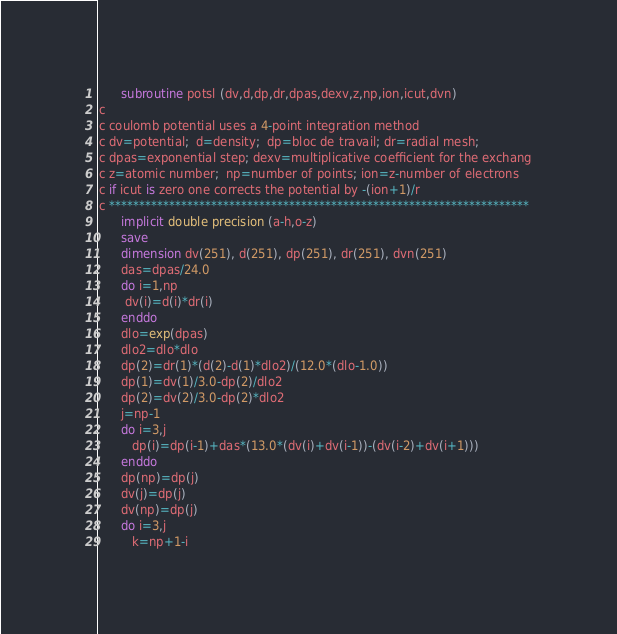Convert code to text. <code><loc_0><loc_0><loc_500><loc_500><_FORTRAN_>      subroutine potsl (dv,d,dp,dr,dpas,dexv,z,np,ion,icut,dvn)
c
c coulomb potential uses a 4-point integration method
c dv=potential;  d=density;  dp=bloc de travail; dr=radial mesh;
c dpas=exponential step; dexv=multiplicative coefficient for the exchang
c z=atomic number;  np=number of points; ion=z-number of electrons
c if icut is zero one corrects the potential by -(ion+1)/r
c **********************************************************************
      implicit double precision (a-h,o-z)
      save
      dimension dv(251), d(251), dp(251), dr(251), dvn(251)
      das=dpas/24.0
      do i=1,np
       dv(i)=d(i)*dr(i)
      enddo
      dlo=exp(dpas)
      dlo2=dlo*dlo
      dp(2)=dr(1)*(d(2)-d(1)*dlo2)/(12.0*(dlo-1.0))
      dp(1)=dv(1)/3.0-dp(2)/dlo2
      dp(2)=dv(2)/3.0-dp(2)*dlo2
      j=np-1
      do i=3,j
         dp(i)=dp(i-1)+das*(13.0*(dv(i)+dv(i-1))-(dv(i-2)+dv(i+1)))
      enddo
      dp(np)=dp(j)
      dv(j)=dp(j)
      dv(np)=dp(j)
      do i=3,j
         k=np+1-i</code> 